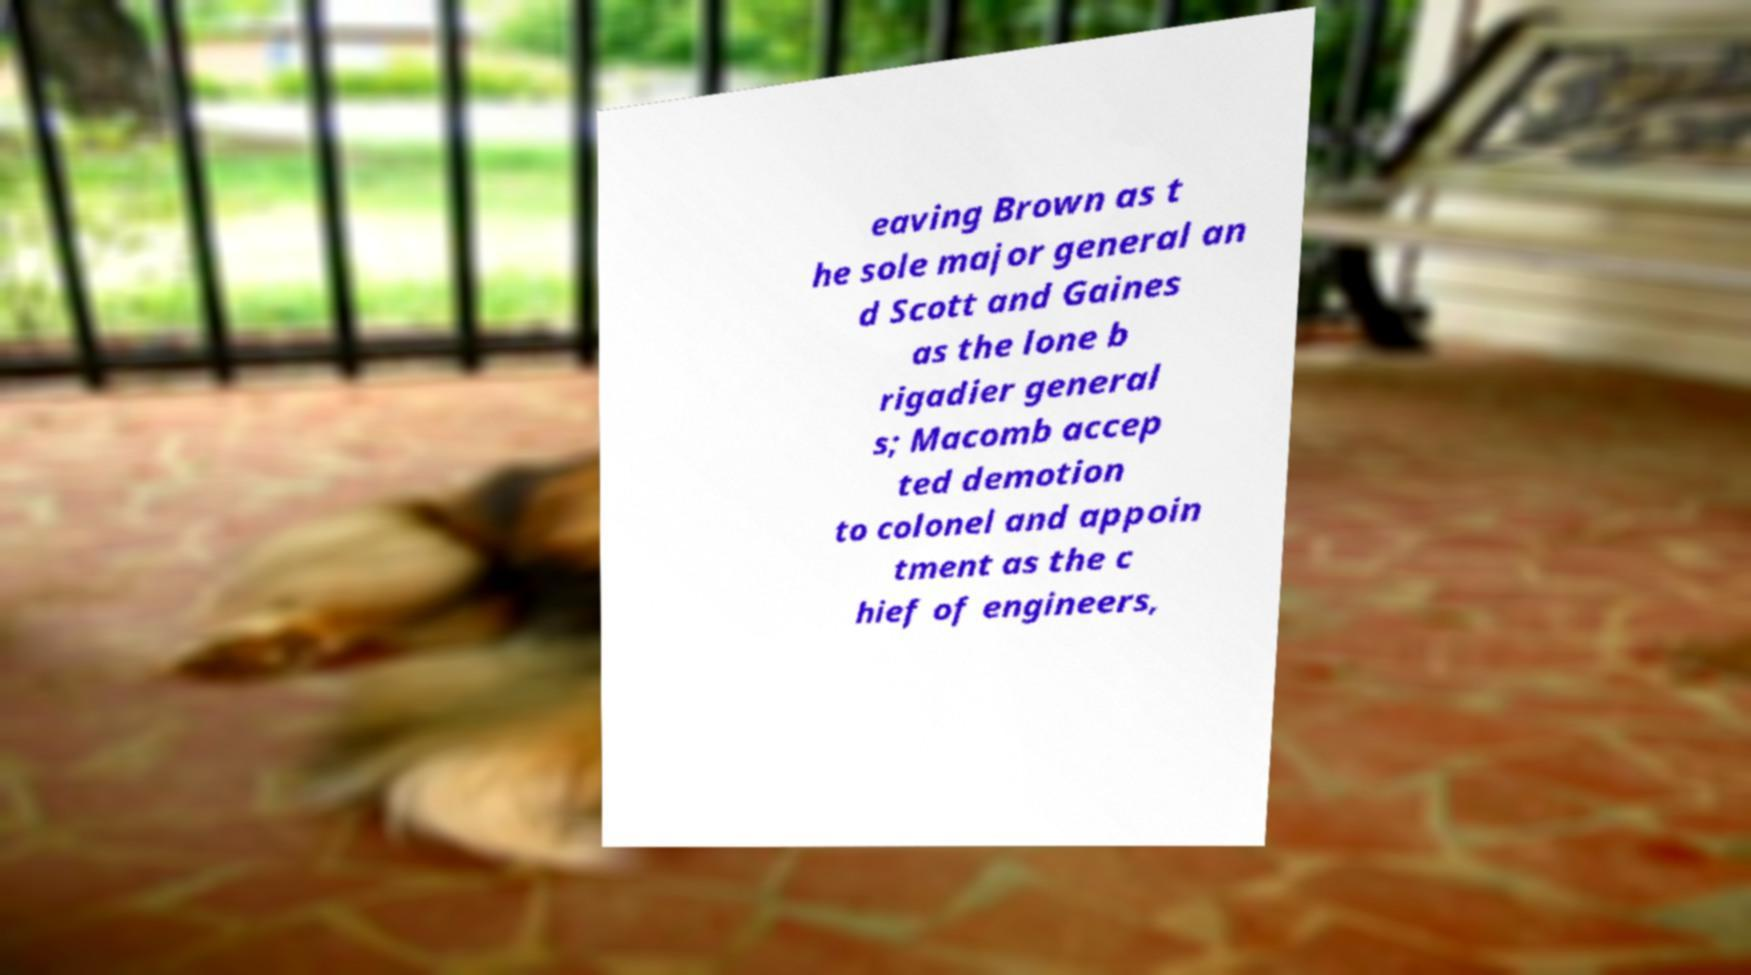Can you read and provide the text displayed in the image?This photo seems to have some interesting text. Can you extract and type it out for me? eaving Brown as t he sole major general an d Scott and Gaines as the lone b rigadier general s; Macomb accep ted demotion to colonel and appoin tment as the c hief of engineers, 